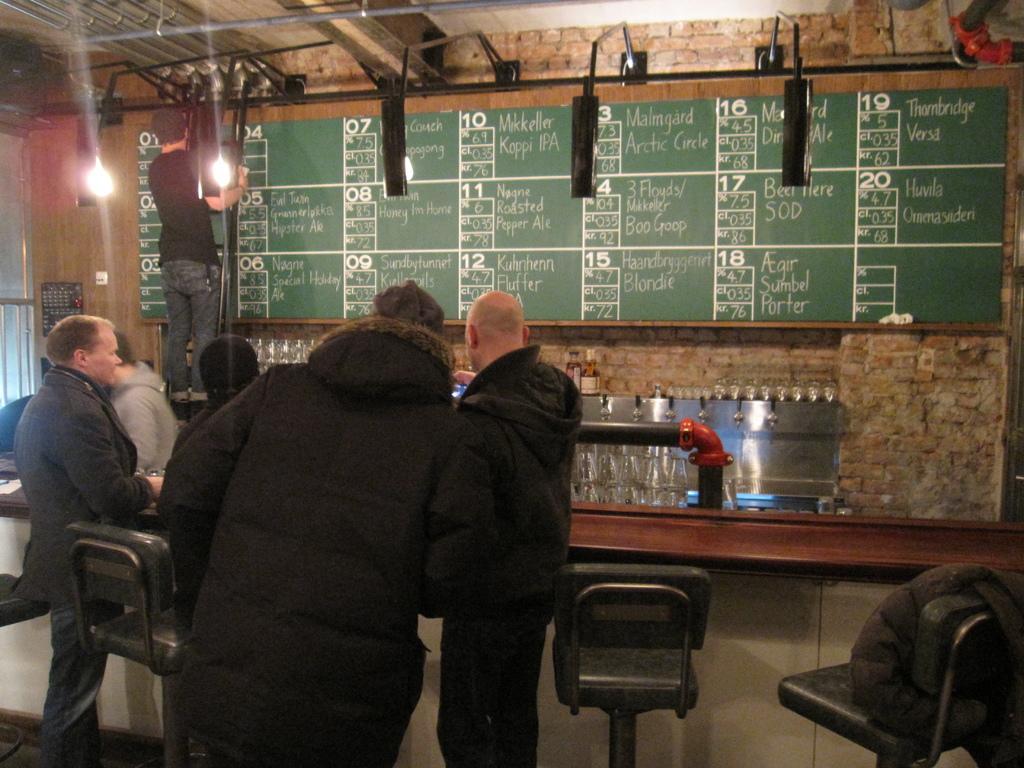In one or two sentences, can you explain what this image depicts? In the given picture, we can see the board and there is something written on it, after that we can see the wall and the roof included with lights, towards the left, we can see the person standing on the ladder, next we can see three people standing on the floor and we can see a few empty chairs. 